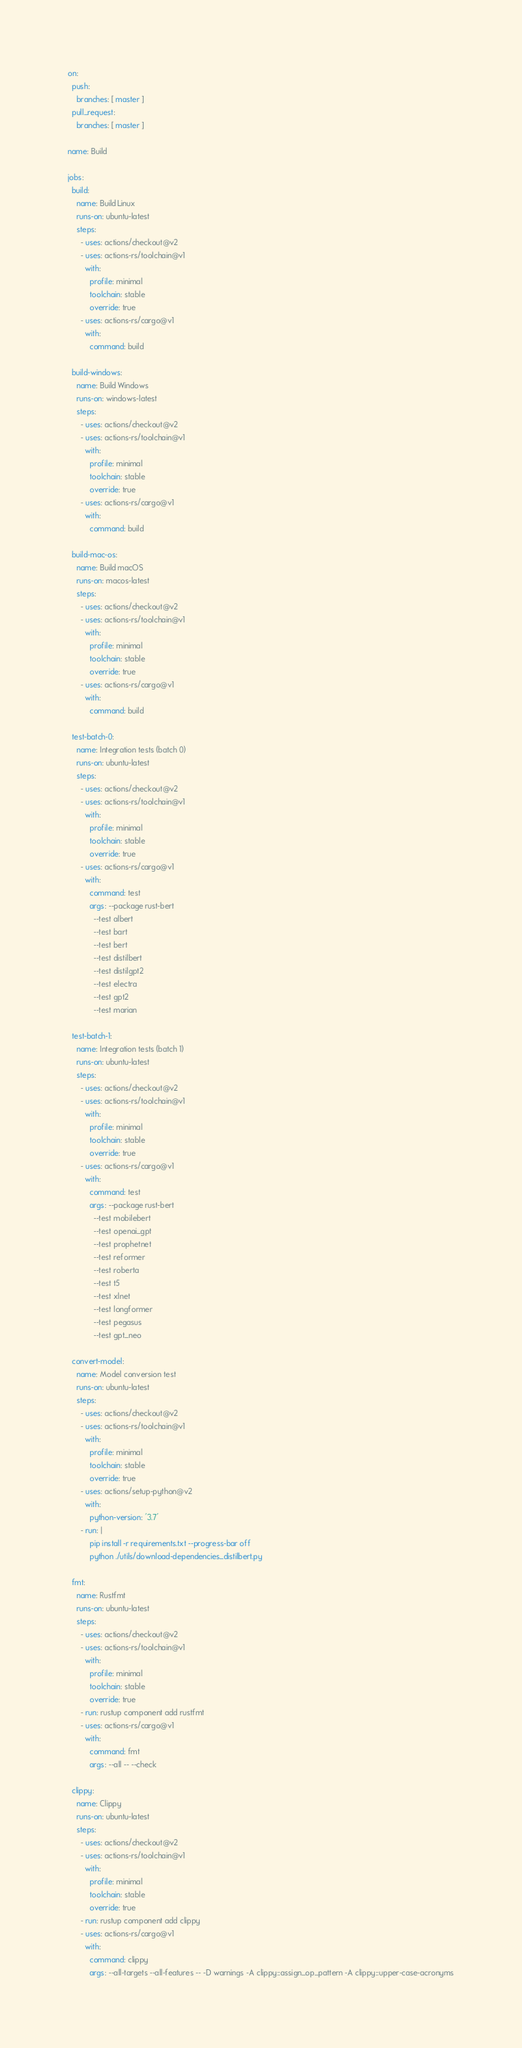<code> <loc_0><loc_0><loc_500><loc_500><_YAML_>on:
  push:
    branches: [ master ]
  pull_request:
    branches: [ master ]

name: Build

jobs:
  build:
    name: Build Linux
    runs-on: ubuntu-latest
    steps:
      - uses: actions/checkout@v2
      - uses: actions-rs/toolchain@v1
        with:
          profile: minimal
          toolchain: stable
          override: true
      - uses: actions-rs/cargo@v1
        with:
          command: build

  build-windows:
    name: Build Windows
    runs-on: windows-latest
    steps:
      - uses: actions/checkout@v2
      - uses: actions-rs/toolchain@v1
        with:
          profile: minimal
          toolchain: stable
          override: true
      - uses: actions-rs/cargo@v1
        with:
          command: build

  build-mac-os:
    name: Build macOS
    runs-on: macos-latest
    steps:
      - uses: actions/checkout@v2
      - uses: actions-rs/toolchain@v1
        with:
          profile: minimal
          toolchain: stable
          override: true
      - uses: actions-rs/cargo@v1
        with:
          command: build

  test-batch-0:
    name: Integration tests (batch 0)
    runs-on: ubuntu-latest
    steps:
      - uses: actions/checkout@v2
      - uses: actions-rs/toolchain@v1
        with:
          profile: minimal
          toolchain: stable
          override: true
      - uses: actions-rs/cargo@v1
        with:
          command: test
          args: --package rust-bert
            --test albert
            --test bart
            --test bert
            --test distilbert
            --test distilgpt2
            --test electra
            --test gpt2
            --test marian

  test-batch-1:
    name: Integration tests (batch 1)
    runs-on: ubuntu-latest
    steps:
      - uses: actions/checkout@v2
      - uses: actions-rs/toolchain@v1
        with:
          profile: minimal
          toolchain: stable
          override: true
      - uses: actions-rs/cargo@v1
        with:
          command: test
          args: --package rust-bert
            --test mobilebert
            --test openai_gpt
            --test prophetnet
            --test reformer
            --test roberta
            --test t5
            --test xlnet
            --test longformer
            --test pegasus
            --test gpt_neo

  convert-model:
    name: Model conversion test
    runs-on: ubuntu-latest
    steps:
      - uses: actions/checkout@v2
      - uses: actions-rs/toolchain@v1
        with:
          profile: minimal
          toolchain: stable
          override: true
      - uses: actions/setup-python@v2
        with:
          python-version: '3.7'
      - run: |
          pip install -r requirements.txt --progress-bar off
          python ./utils/download-dependencies_distilbert.py

  fmt:
    name: Rustfmt
    runs-on: ubuntu-latest
    steps:
      - uses: actions/checkout@v2
      - uses: actions-rs/toolchain@v1
        with:
          profile: minimal
          toolchain: stable
          override: true
      - run: rustup component add rustfmt
      - uses: actions-rs/cargo@v1
        with:
          command: fmt
          args: --all -- --check

  clippy:
    name: Clippy
    runs-on: ubuntu-latest
    steps:
      - uses: actions/checkout@v2
      - uses: actions-rs/toolchain@v1
        with:
          profile: minimal
          toolchain: stable
          override: true
      - run: rustup component add clippy
      - uses: actions-rs/cargo@v1
        with:
          command: clippy
          args: --all-targets --all-features -- -D warnings -A clippy::assign_op_pattern -A clippy::upper-case-acronyms</code> 